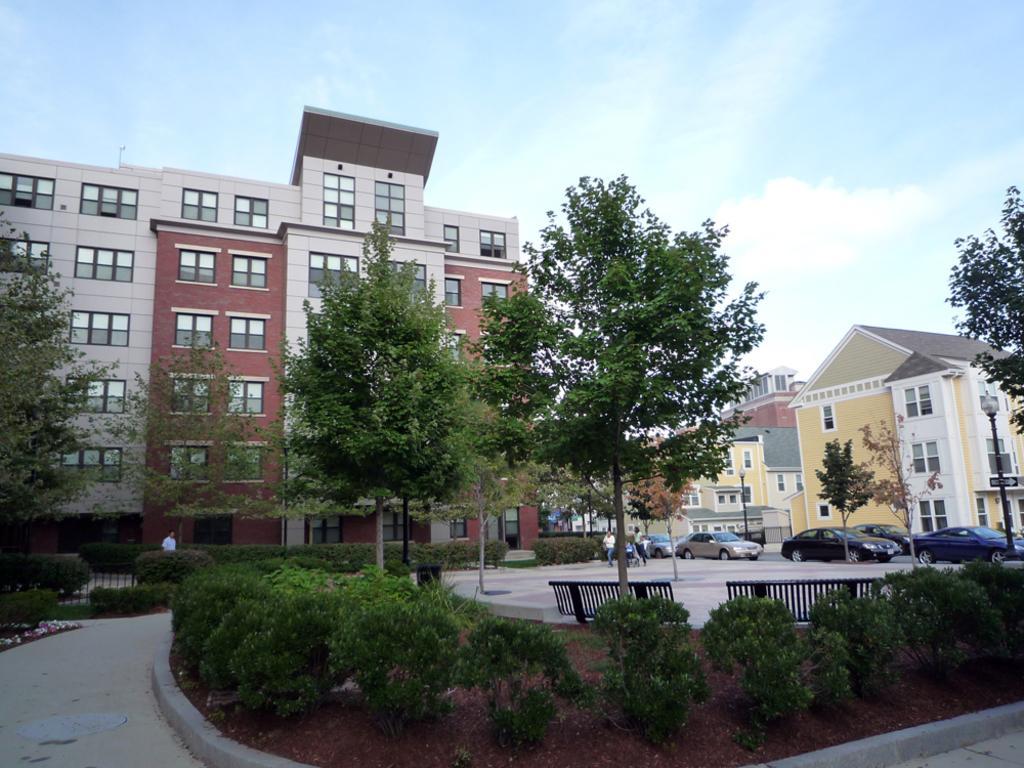Describe this image in one or two sentences. In this image in the center there are some buildings, houses and some cars and some people. At the bottom there are some plants, sand and benches and a walkway. At the top of the image there is sky, and in the center there are some poles and lights. 